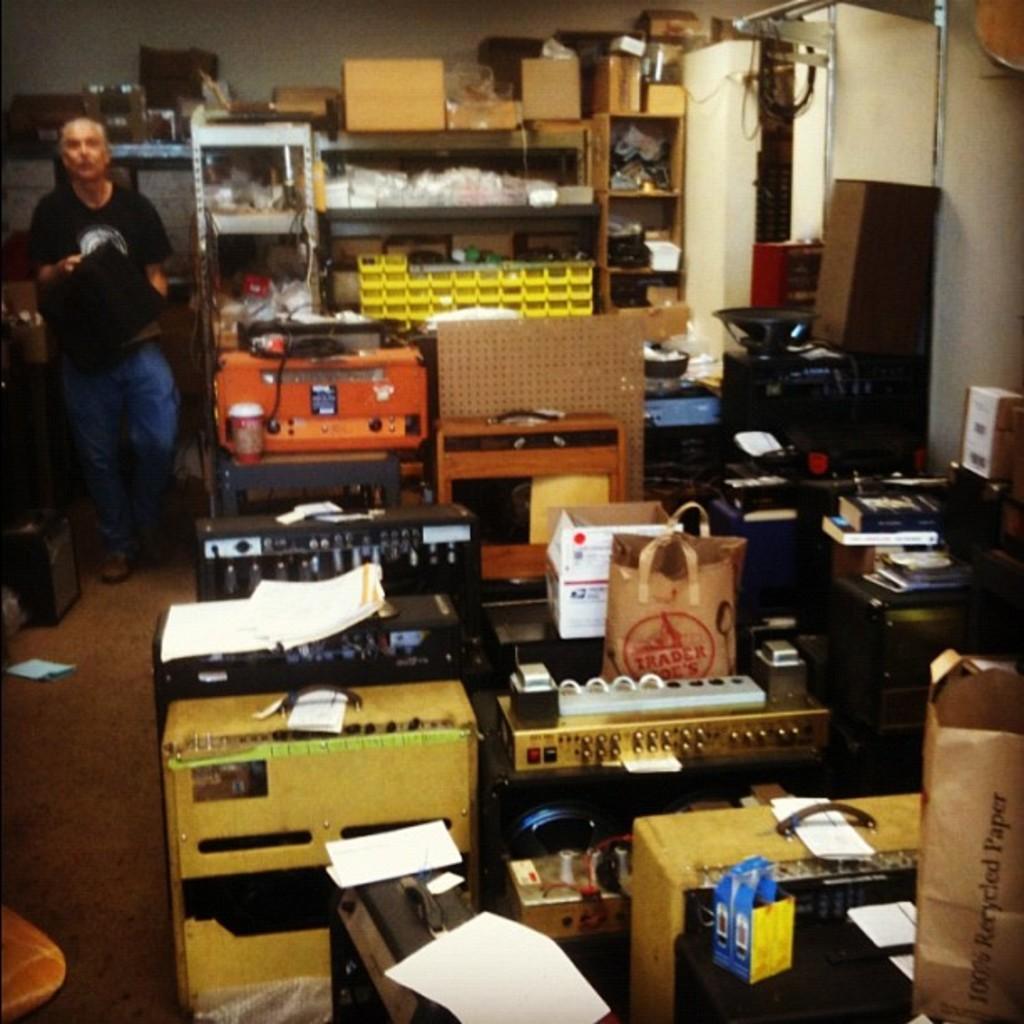Could you give a brief overview of what you see in this image? In this image in the center there are some machines, boxes, papers and bags, wires, and in the background there are some shelves. In the shelves there are objects, and on the shelves there are some boxes and on the left side there is one person standing and beside him there are some boxes. And in the top right hand corner there is wall, pole and some boxes and machines. At the bottom there is floor. 